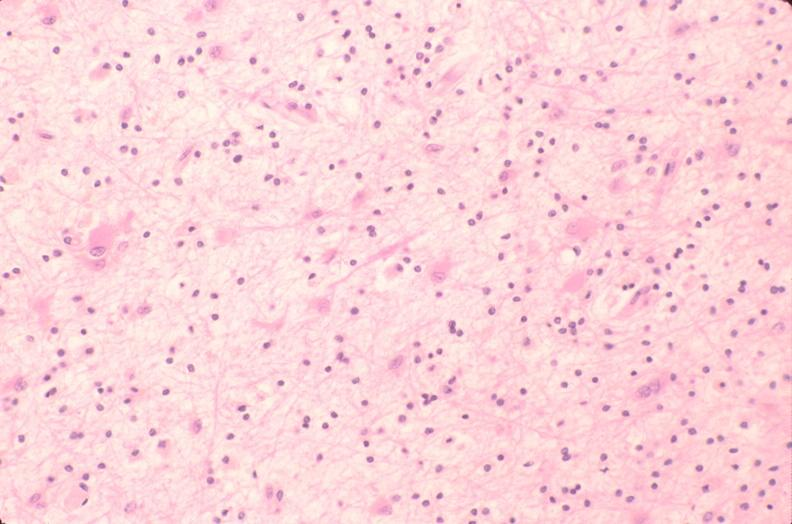what does this image show?
Answer the question using a single word or phrase. Brain 